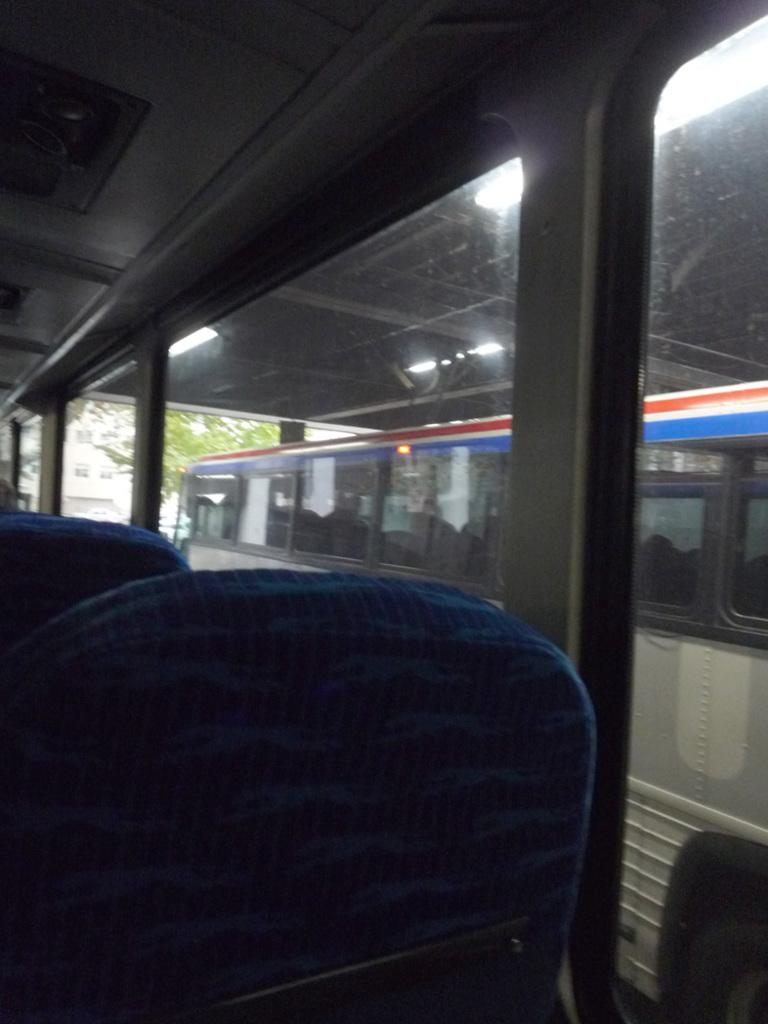What can be seen on the path in the image? There are vehicles on the path in the image. What is visible in the background of the image? There is a tree and a building in the background of the image. How many girls are skating on the path in the image? There are no girls or skating activity present in the image; it features vehicles on the path and a tree and building in the background. 